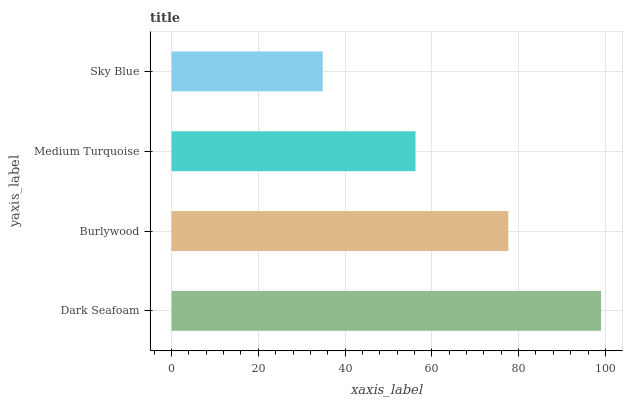Is Sky Blue the minimum?
Answer yes or no. Yes. Is Dark Seafoam the maximum?
Answer yes or no. Yes. Is Burlywood the minimum?
Answer yes or no. No. Is Burlywood the maximum?
Answer yes or no. No. Is Dark Seafoam greater than Burlywood?
Answer yes or no. Yes. Is Burlywood less than Dark Seafoam?
Answer yes or no. Yes. Is Burlywood greater than Dark Seafoam?
Answer yes or no. No. Is Dark Seafoam less than Burlywood?
Answer yes or no. No. Is Burlywood the high median?
Answer yes or no. Yes. Is Medium Turquoise the low median?
Answer yes or no. Yes. Is Dark Seafoam the high median?
Answer yes or no. No. Is Burlywood the low median?
Answer yes or no. No. 